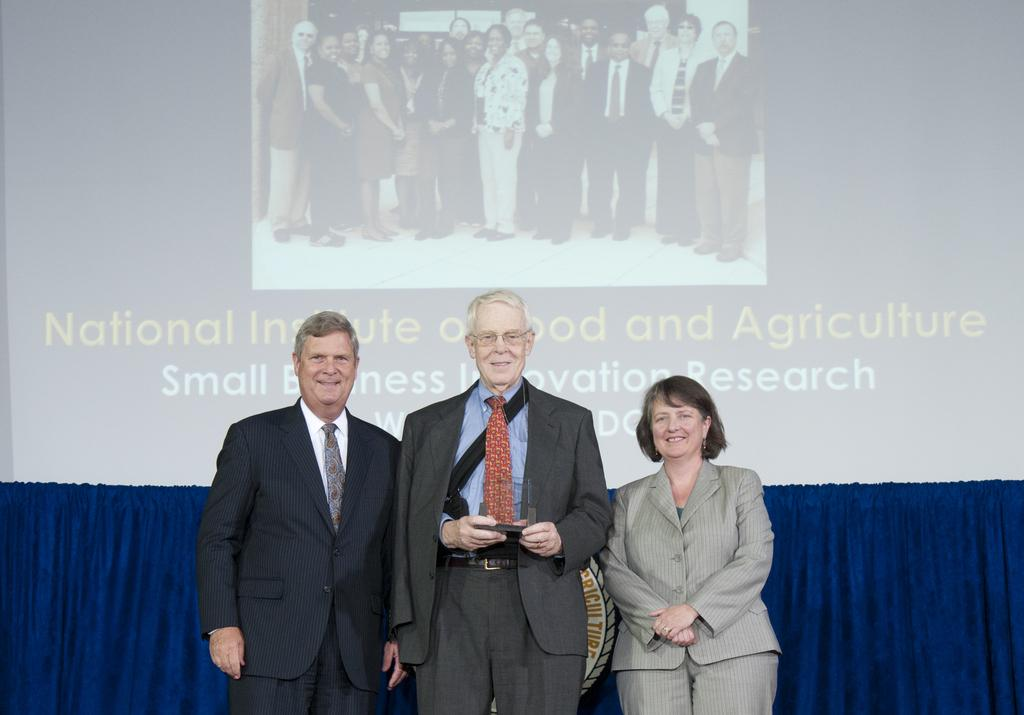How many people are in the image? There are two men and one woman in the image. What are the people in the image doing? The people are standing and smiling. What can be seen on the screen in the image? There is a display on the screen in the image. What color is the cloth hanging in the image? The cloth hanging in the image is blue. How many flies can be seen buzzing around the display on the screen in the image? There are no flies visible in the image, and therefore no such activity can be observed. 